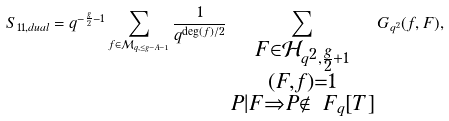Convert formula to latex. <formula><loc_0><loc_0><loc_500><loc_500>S _ { 1 1 , d u a l } = q ^ { - \frac { g } { 2 } - 1 } \sum _ { f \in \mathcal { M } _ { q , \leq g - A - 1 } } \frac { 1 } { q ^ { \deg ( f ) / 2 } } \sum _ { \substack { F \in \mathcal { H } _ { q ^ { 2 } , \frac { g } { 2 } + 1 } \\ ( F , f ) = 1 \\ P | F \Rightarrow P \not \in \ F _ { q } [ T ] } } G _ { q ^ { 2 } } ( f , F ) ,</formula> 